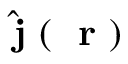<formula> <loc_0><loc_0><loc_500><loc_500>\hat { j } ( r )</formula> 